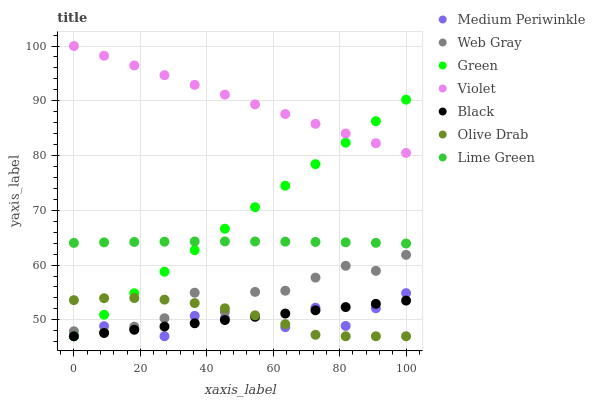Does Medium Periwinkle have the minimum area under the curve?
Answer yes or no. Yes. Does Violet have the maximum area under the curve?
Answer yes or no. Yes. Does Green have the minimum area under the curve?
Answer yes or no. No. Does Green have the maximum area under the curve?
Answer yes or no. No. Is Violet the smoothest?
Answer yes or no. Yes. Is Medium Periwinkle the roughest?
Answer yes or no. Yes. Is Green the smoothest?
Answer yes or no. No. Is Green the roughest?
Answer yes or no. No. Does Medium Periwinkle have the lowest value?
Answer yes or no. Yes. Does Violet have the lowest value?
Answer yes or no. No. Does Violet have the highest value?
Answer yes or no. Yes. Does Medium Periwinkle have the highest value?
Answer yes or no. No. Is Olive Drab less than Lime Green?
Answer yes or no. Yes. Is Web Gray greater than Black?
Answer yes or no. Yes. Does Web Gray intersect Medium Periwinkle?
Answer yes or no. Yes. Is Web Gray less than Medium Periwinkle?
Answer yes or no. No. Is Web Gray greater than Medium Periwinkle?
Answer yes or no. No. Does Olive Drab intersect Lime Green?
Answer yes or no. No. 